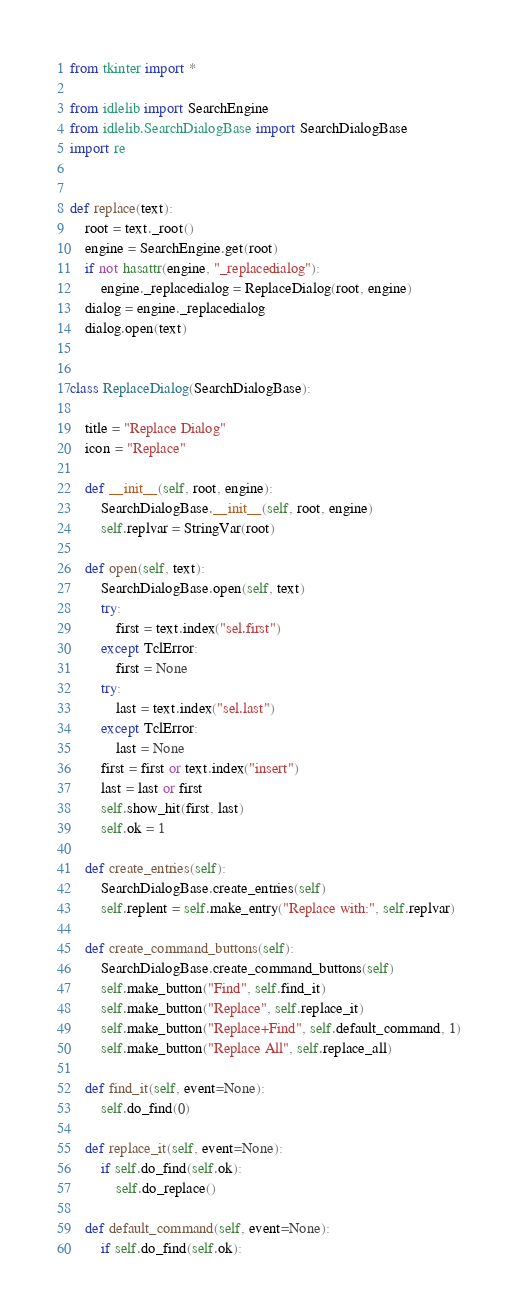<code> <loc_0><loc_0><loc_500><loc_500><_Python_>from tkinter import *

from idlelib import SearchEngine
from idlelib.SearchDialogBase import SearchDialogBase
import re


def replace(text):
    root = text._root()
    engine = SearchEngine.get(root)
    if not hasattr(engine, "_replacedialog"):
        engine._replacedialog = ReplaceDialog(root, engine)
    dialog = engine._replacedialog
    dialog.open(text)


class ReplaceDialog(SearchDialogBase):

    title = "Replace Dialog"
    icon = "Replace"

    def __init__(self, root, engine):
        SearchDialogBase.__init__(self, root, engine)
        self.replvar = StringVar(root)

    def open(self, text):
        SearchDialogBase.open(self, text)
        try:
            first = text.index("sel.first")
        except TclError:
            first = None
        try:
            last = text.index("sel.last")
        except TclError:
            last = None
        first = first or text.index("insert")
        last = last or first
        self.show_hit(first, last)
        self.ok = 1

    def create_entries(self):
        SearchDialogBase.create_entries(self)
        self.replent = self.make_entry("Replace with:", self.replvar)

    def create_command_buttons(self):
        SearchDialogBase.create_command_buttons(self)
        self.make_button("Find", self.find_it)
        self.make_button("Replace", self.replace_it)
        self.make_button("Replace+Find", self.default_command, 1)
        self.make_button("Replace All", self.replace_all)

    def find_it(self, event=None):
        self.do_find(0)

    def replace_it(self, event=None):
        if self.do_find(self.ok):
            self.do_replace()

    def default_command(self, event=None):
        if self.do_find(self.ok):</code> 